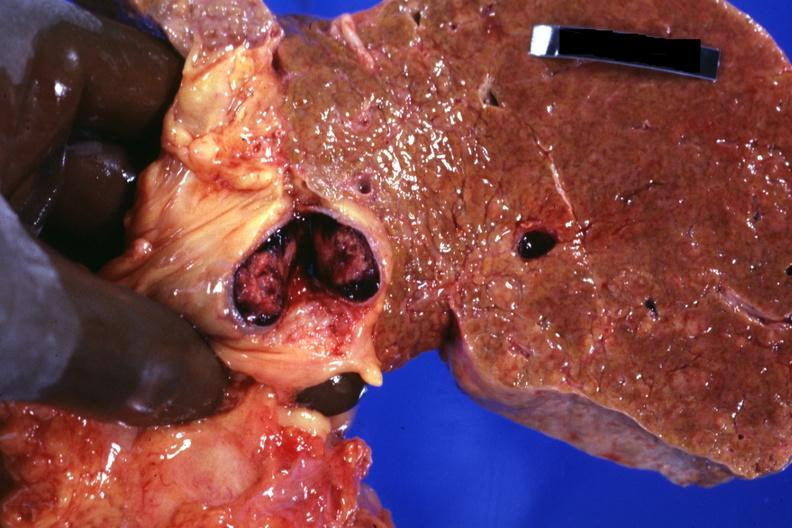what is present?
Answer the question using a single word or phrase. Hepatobiliary 